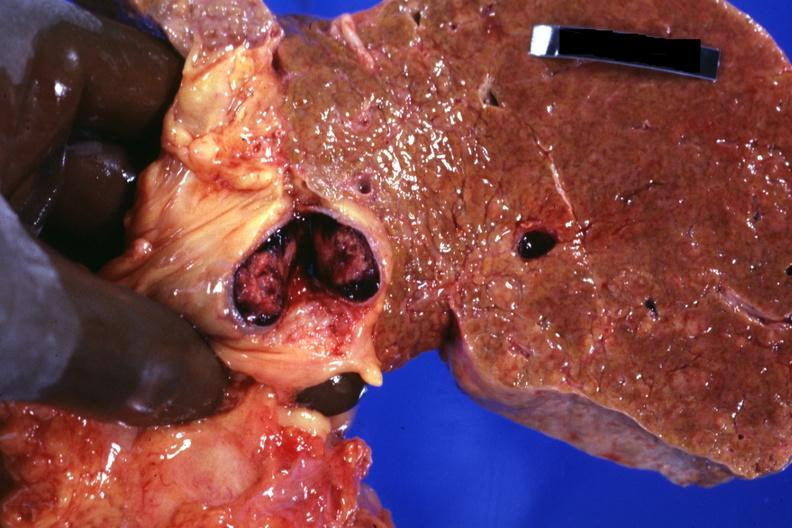what is present?
Answer the question using a single word or phrase. Hepatobiliary 